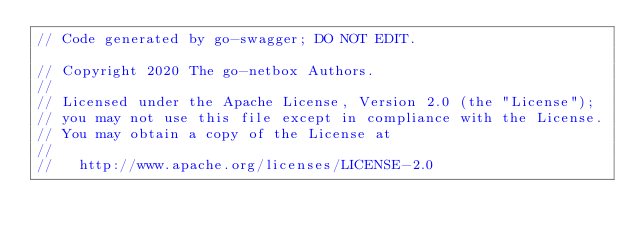Convert code to text. <code><loc_0><loc_0><loc_500><loc_500><_Go_>// Code generated by go-swagger; DO NOT EDIT.

// Copyright 2020 The go-netbox Authors.
//
// Licensed under the Apache License, Version 2.0 (the "License");
// you may not use this file except in compliance with the License.
// You may obtain a copy of the License at
//
//   http://www.apache.org/licenses/LICENSE-2.0</code> 